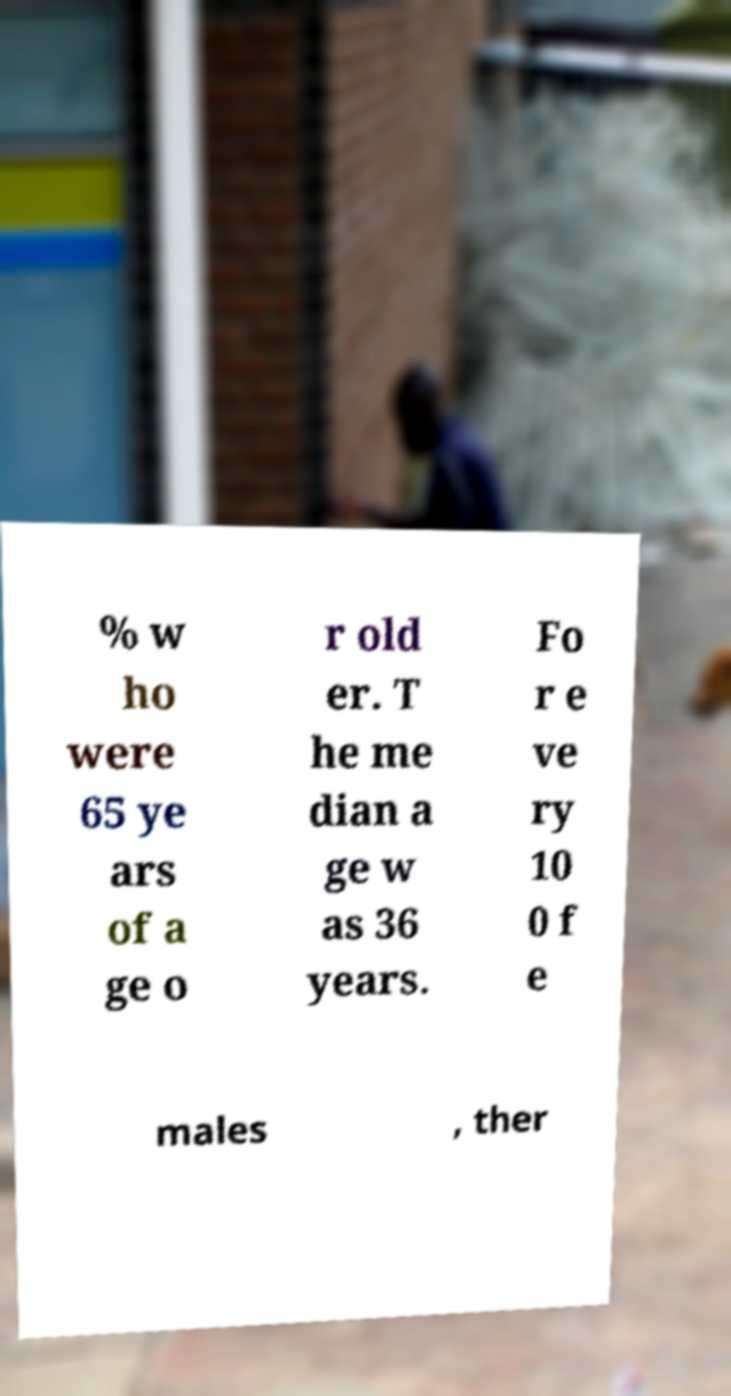Please identify and transcribe the text found in this image. % w ho were 65 ye ars of a ge o r old er. T he me dian a ge w as 36 years. Fo r e ve ry 10 0 f e males , ther 